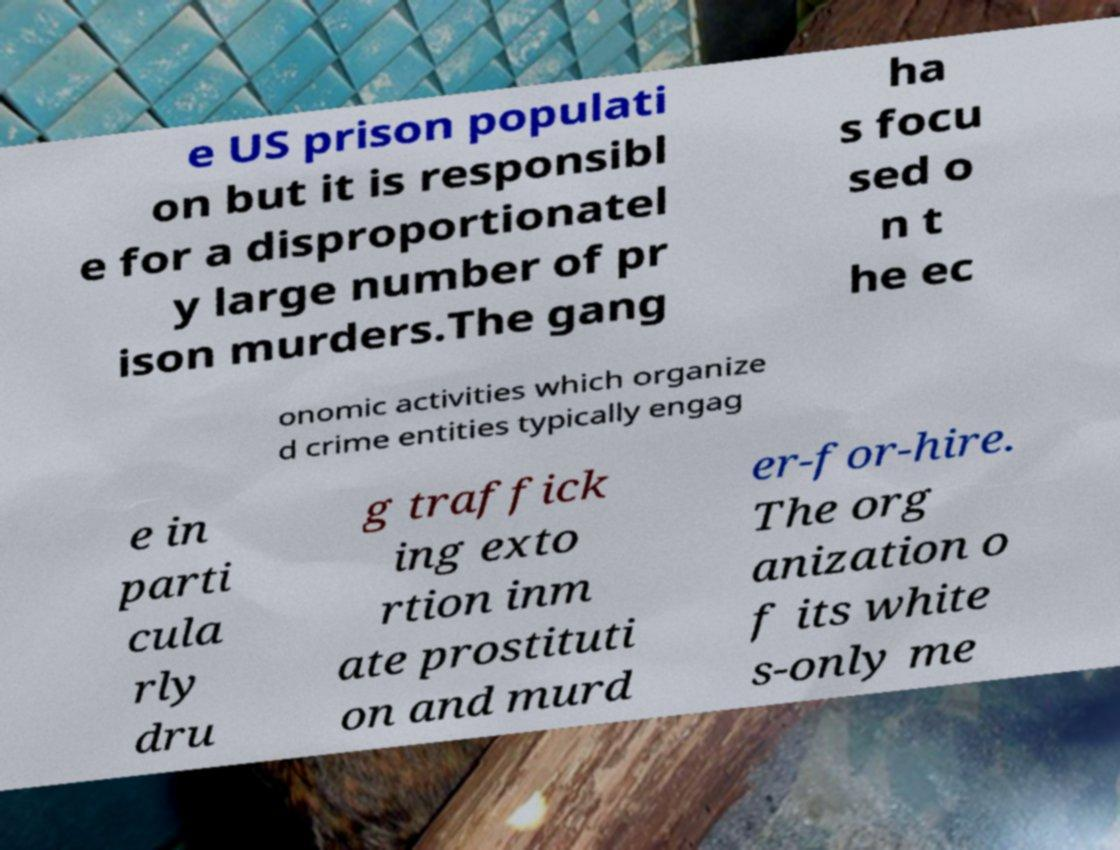I need the written content from this picture converted into text. Can you do that? e US prison populati on but it is responsibl e for a disproportionatel y large number of pr ison murders.The gang ha s focu sed o n t he ec onomic activities which organize d crime entities typically engag e in parti cula rly dru g traffick ing exto rtion inm ate prostituti on and murd er-for-hire. The org anization o f its white s-only me 